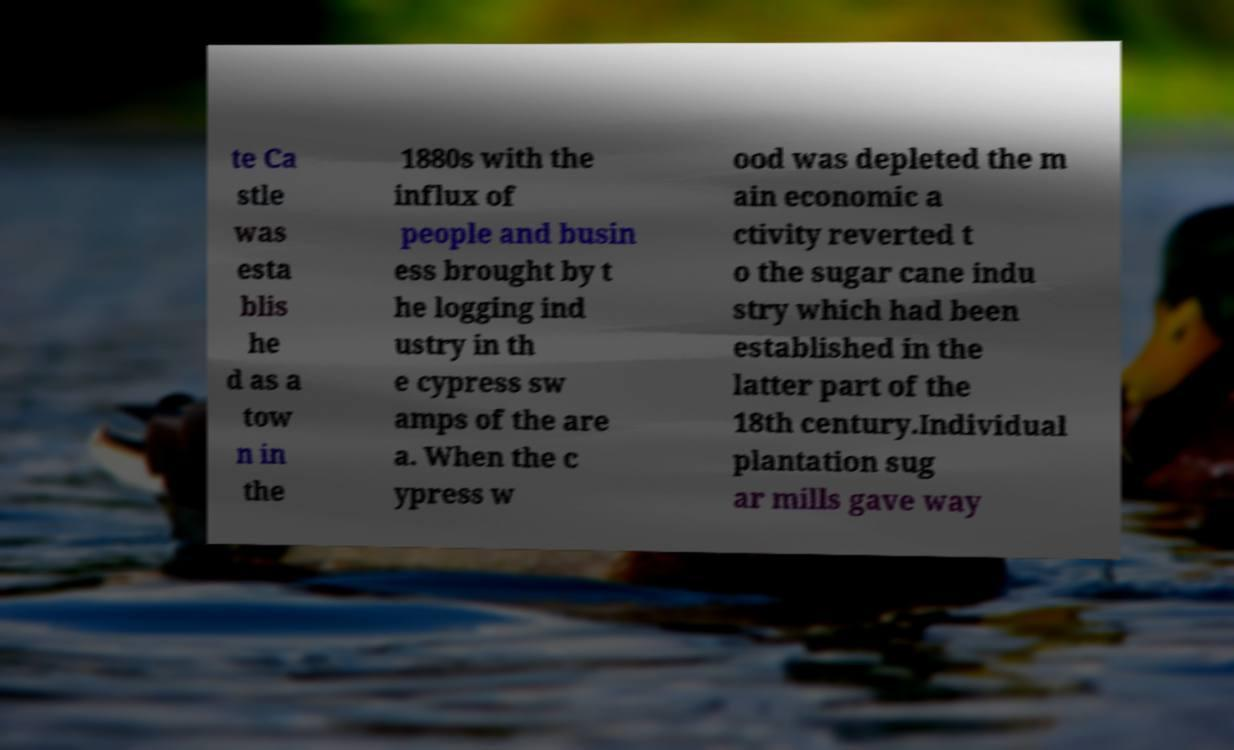Can you read and provide the text displayed in the image?This photo seems to have some interesting text. Can you extract and type it out for me? te Ca stle was esta blis he d as a tow n in the 1880s with the influx of people and busin ess brought by t he logging ind ustry in th e cypress sw amps of the are a. When the c ypress w ood was depleted the m ain economic a ctivity reverted t o the sugar cane indu stry which had been established in the latter part of the 18th century.Individual plantation sug ar mills gave way 